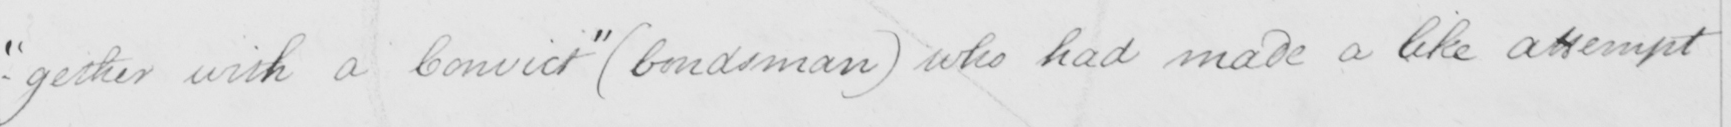Please provide the text content of this handwritten line. - " gether with a Convict "   ( bondsman )  who had made a like attempt 